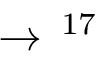<formula> <loc_0><loc_0><loc_500><loc_500>\to \, ^ { 1 7 }</formula> 